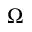<formula> <loc_0><loc_0><loc_500><loc_500>\Omega</formula> 